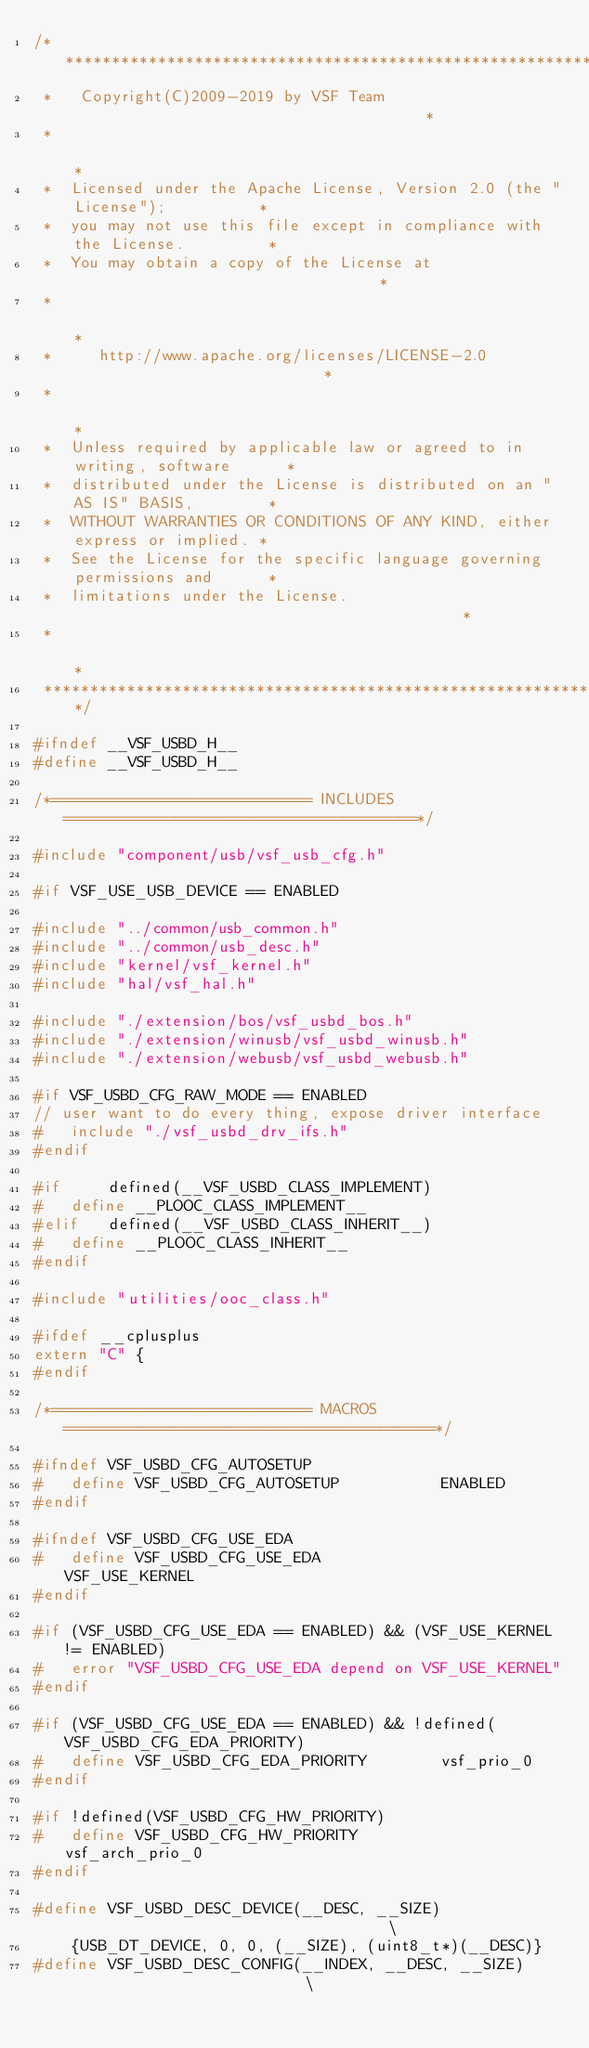<code> <loc_0><loc_0><loc_500><loc_500><_C_>/*****************************************************************************
 *   Copyright(C)2009-2019 by VSF Team                                       *
 *                                                                           *
 *  Licensed under the Apache License, Version 2.0 (the "License");          *
 *  you may not use this file except in compliance with the License.         *
 *  You may obtain a copy of the License at                                  *
 *                                                                           *
 *     http://www.apache.org/licenses/LICENSE-2.0                            *
 *                                                                           *
 *  Unless required by applicable law or agreed to in writing, software      *
 *  distributed under the License is distributed on an "AS IS" BASIS,        *
 *  WITHOUT WARRANTIES OR CONDITIONS OF ANY KIND, either express or implied. *
 *  See the License for the specific language governing permissions and      *
 *  limitations under the License.                                           *
 *                                                                           *
 ****************************************************************************/

#ifndef __VSF_USBD_H__
#define __VSF_USBD_H__

/*============================ INCLUDES ======================================*/

#include "component/usb/vsf_usb_cfg.h"

#if VSF_USE_USB_DEVICE == ENABLED

#include "../common/usb_common.h"
#include "../common/usb_desc.h"
#include "kernel/vsf_kernel.h"
#include "hal/vsf_hal.h"

#include "./extension/bos/vsf_usbd_bos.h"
#include "./extension/winusb/vsf_usbd_winusb.h"
#include "./extension/webusb/vsf_usbd_webusb.h"

#if VSF_USBD_CFG_RAW_MODE == ENABLED
// user want to do every thing, expose driver interface
#   include "./vsf_usbd_drv_ifs.h"
#endif

#if     defined(__VSF_USBD_CLASS_IMPLEMENT)
#   define __PLOOC_CLASS_IMPLEMENT__
#elif   defined(__VSF_USBD_CLASS_INHERIT__)
#   define __PLOOC_CLASS_INHERIT__
#endif

#include "utilities/ooc_class.h"

#ifdef __cplusplus
extern "C" {
#endif

/*============================ MACROS ========================================*/

#ifndef VSF_USBD_CFG_AUTOSETUP
#   define VSF_USBD_CFG_AUTOSETUP           ENABLED
#endif

#ifndef VSF_USBD_CFG_USE_EDA
#   define VSF_USBD_CFG_USE_EDA             VSF_USE_KERNEL
#endif

#if (VSF_USBD_CFG_USE_EDA == ENABLED) && (VSF_USE_KERNEL != ENABLED)
#   error "VSF_USBD_CFG_USE_EDA depend on VSF_USE_KERNEL"
#endif

#if (VSF_USBD_CFG_USE_EDA == ENABLED) && !defined(VSF_USBD_CFG_EDA_PRIORITY)
#   define VSF_USBD_CFG_EDA_PRIORITY        vsf_prio_0
#endif

#if !defined(VSF_USBD_CFG_HW_PRIORITY)
#   define VSF_USBD_CFG_HW_PRIORITY         vsf_arch_prio_0
#endif

#define VSF_USBD_DESC_DEVICE(__DESC, __SIZE)                                    \
    {USB_DT_DEVICE, 0, 0, (__SIZE), (uint8_t*)(__DESC)}
#define VSF_USBD_DESC_CONFIG(__INDEX, __DESC, __SIZE)                           \</code> 